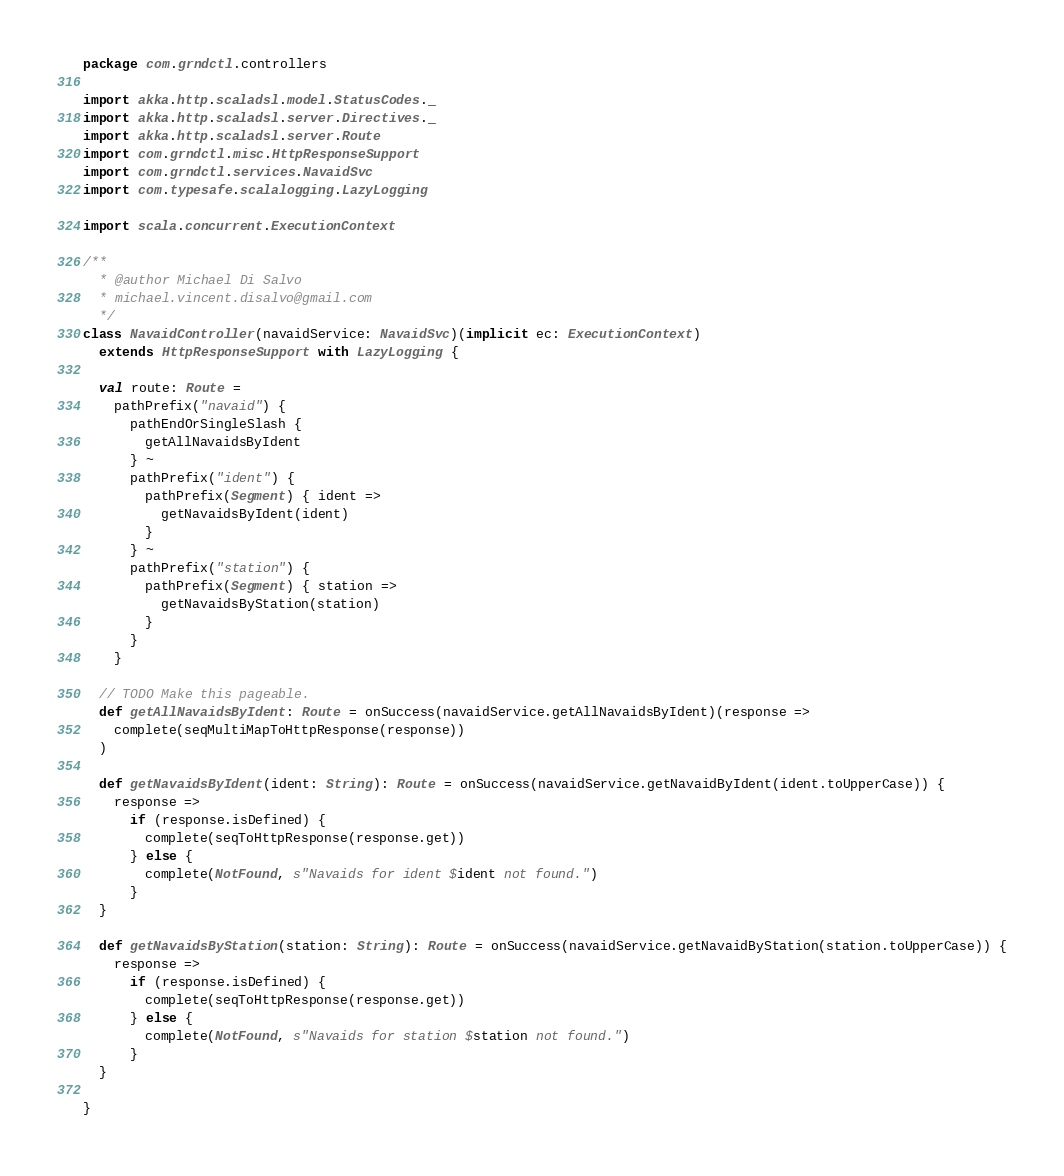Convert code to text. <code><loc_0><loc_0><loc_500><loc_500><_Scala_>package com.grndctl.controllers

import akka.http.scaladsl.model.StatusCodes._
import akka.http.scaladsl.server.Directives._
import akka.http.scaladsl.server.Route
import com.grndctl.misc.HttpResponseSupport
import com.grndctl.services.NavaidSvc
import com.typesafe.scalalogging.LazyLogging

import scala.concurrent.ExecutionContext

/**
  * @author Michael Di Salvo
  * michael.vincent.disalvo@gmail.com
  */
class NavaidController(navaidService: NavaidSvc)(implicit ec: ExecutionContext)
  extends HttpResponseSupport with LazyLogging {

  val route: Route =
    pathPrefix("navaid") {
      pathEndOrSingleSlash {
        getAllNavaidsByIdent
      } ~
      pathPrefix("ident") {
        pathPrefix(Segment) { ident =>
          getNavaidsByIdent(ident)
        }
      } ~
      pathPrefix("station") {
        pathPrefix(Segment) { station =>
          getNavaidsByStation(station)
        }
      }
    }

  // TODO Make this pageable.
  def getAllNavaidsByIdent: Route = onSuccess(navaidService.getAllNavaidsByIdent)(response =>
    complete(seqMultiMapToHttpResponse(response))
  )

  def getNavaidsByIdent(ident: String): Route = onSuccess(navaidService.getNavaidByIdent(ident.toUpperCase)) {
    response =>
      if (response.isDefined) {
        complete(seqToHttpResponse(response.get))
      } else {
        complete(NotFound, s"Navaids for ident $ident not found.")
      }
  }

  def getNavaidsByStation(station: String): Route = onSuccess(navaidService.getNavaidByStation(station.toUpperCase)) {
    response =>
      if (response.isDefined) {
        complete(seqToHttpResponse(response.get))
      } else {
        complete(NotFound, s"Navaids for station $station not found.")
      }
  }

}
</code> 